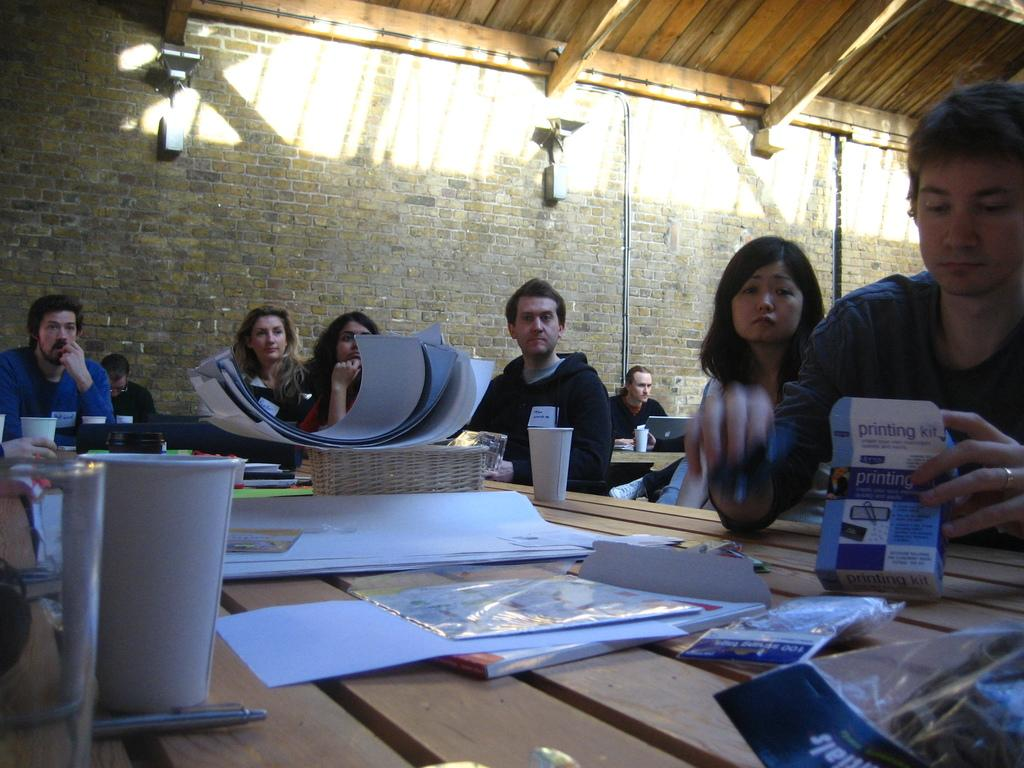What are the people in the image doing? The people in the image are sitting. What is present in the image that the people might be using? There is a table in the image that the people might be using. What can be seen on the table in the image? There are various items on the table in the image. What can be seen in the background of the image? There is a wall visible in the background of the image. Is there a volcano erupting in the image? No, there is no volcano present in the image. What type of coil is being used to generate heat in the image? There is no coil or heat generation visible in the image. 